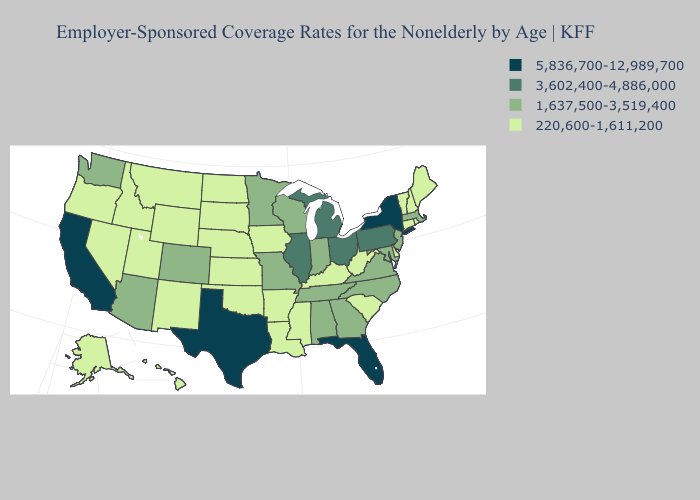What is the highest value in states that border New Jersey?
Keep it brief. 5,836,700-12,989,700. Does South Dakota have the highest value in the USA?
Be succinct. No. What is the lowest value in the MidWest?
Quick response, please. 220,600-1,611,200. What is the value of North Dakota?
Answer briefly. 220,600-1,611,200. What is the highest value in states that border Florida?
Keep it brief. 1,637,500-3,519,400. Name the states that have a value in the range 1,637,500-3,519,400?
Quick response, please. Alabama, Arizona, Colorado, Georgia, Indiana, Maryland, Massachusetts, Minnesota, Missouri, New Jersey, North Carolina, Tennessee, Virginia, Washington, Wisconsin. What is the value of Michigan?
Write a very short answer. 3,602,400-4,886,000. Does the first symbol in the legend represent the smallest category?
Concise answer only. No. Does Washington have the highest value in the USA?
Keep it brief. No. Does the first symbol in the legend represent the smallest category?
Write a very short answer. No. Does Arizona have a higher value than Colorado?
Be succinct. No. Which states have the lowest value in the South?
Be succinct. Arkansas, Delaware, Kentucky, Louisiana, Mississippi, Oklahoma, South Carolina, West Virginia. Which states hav the highest value in the MidWest?
Short answer required. Illinois, Michigan, Ohio. Which states have the highest value in the USA?
Answer briefly. California, Florida, New York, Texas. Name the states that have a value in the range 5,836,700-12,989,700?
Quick response, please. California, Florida, New York, Texas. 